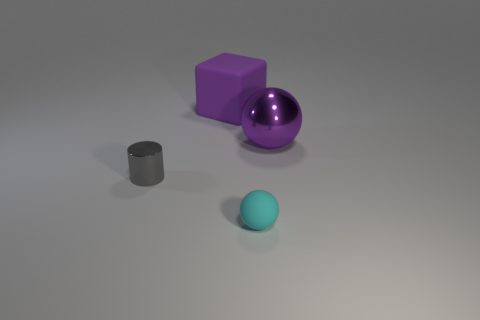Add 3 gray matte objects. How many objects exist? 7 Add 2 small metallic cylinders. How many small metallic cylinders are left? 3 Add 2 gray things. How many gray things exist? 3 Subtract 1 purple spheres. How many objects are left? 3 Subtract all cylinders. How many objects are left? 3 Subtract all purple metal objects. Subtract all gray metal things. How many objects are left? 2 